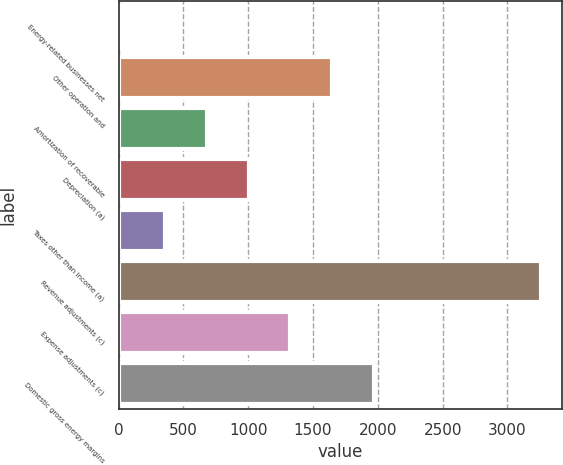Convert chart to OTSL. <chart><loc_0><loc_0><loc_500><loc_500><bar_chart><fcel>Energy-related businesses net<fcel>Other operation and<fcel>Amortization of recoverable<fcel>Depreciation (a)<fcel>Taxes other than income (a)<fcel>Revenue adjustments (c)<fcel>Expense adjustments (c)<fcel>Domestic gross energy margins<nl><fcel>38<fcel>1647<fcel>681.6<fcel>1003.4<fcel>359.8<fcel>3256<fcel>1325.2<fcel>1968.8<nl></chart> 